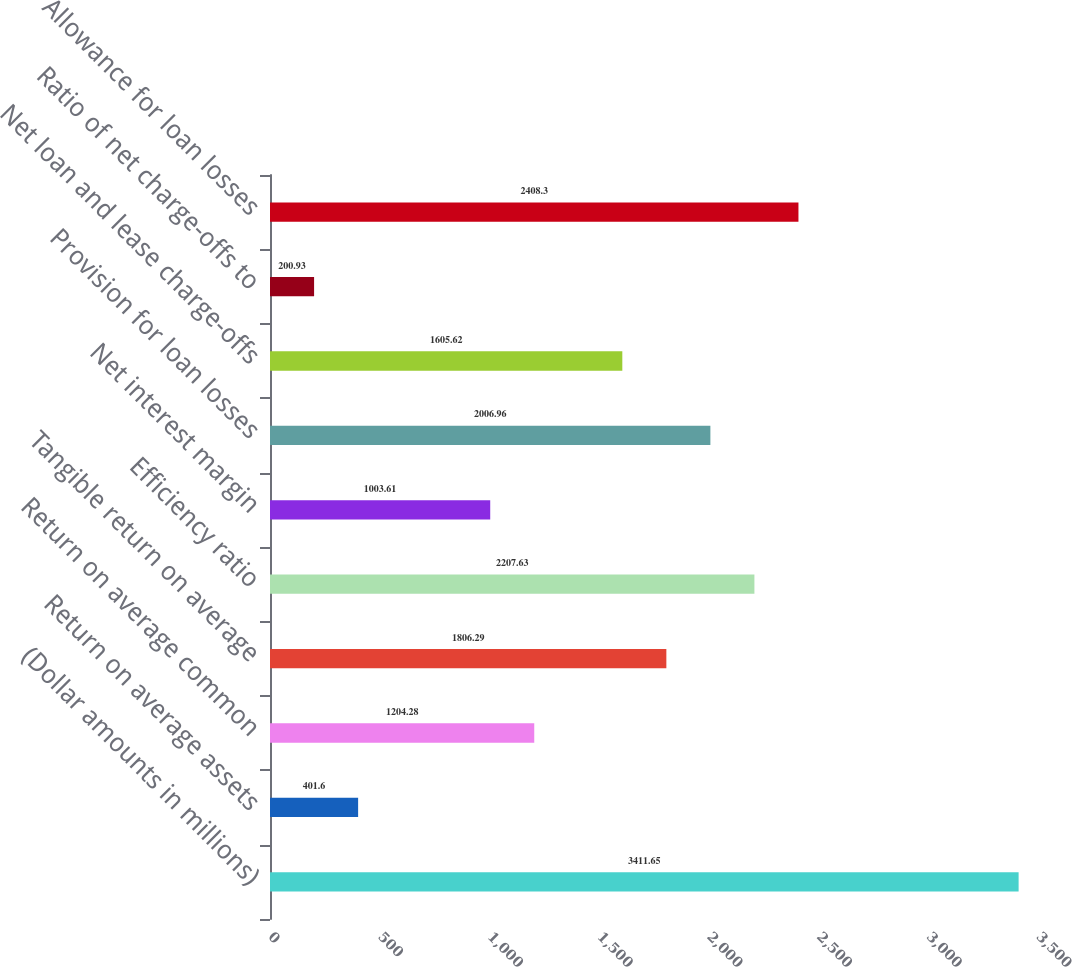<chart> <loc_0><loc_0><loc_500><loc_500><bar_chart><fcel>(Dollar amounts in millions)<fcel>Return on average assets<fcel>Return on average common<fcel>Tangible return on average<fcel>Efficiency ratio<fcel>Net interest margin<fcel>Provision for loan losses<fcel>Net loan and lease charge-offs<fcel>Ratio of net charge-offs to<fcel>Allowance for loan losses<nl><fcel>3411.65<fcel>401.6<fcel>1204.28<fcel>1806.29<fcel>2207.63<fcel>1003.61<fcel>2006.96<fcel>1605.62<fcel>200.93<fcel>2408.3<nl></chart> 